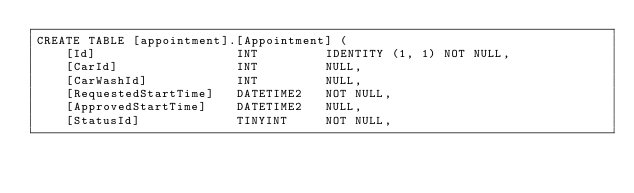Convert code to text. <code><loc_0><loc_0><loc_500><loc_500><_SQL_>CREATE TABLE [appointment].[Appointment] (
    [Id]                   INT         IDENTITY (1, 1) NOT NULL,
    [CarId]                INT         NULL,
    [CarWashId]            INT         NULL,
    [RequestedStartTime]   DATETIME2   NOT NULL,
    [ApprovedStartTime]    DATETIME2   NULL,
    [StatusId]             TINYINT     NOT NULL,</code> 